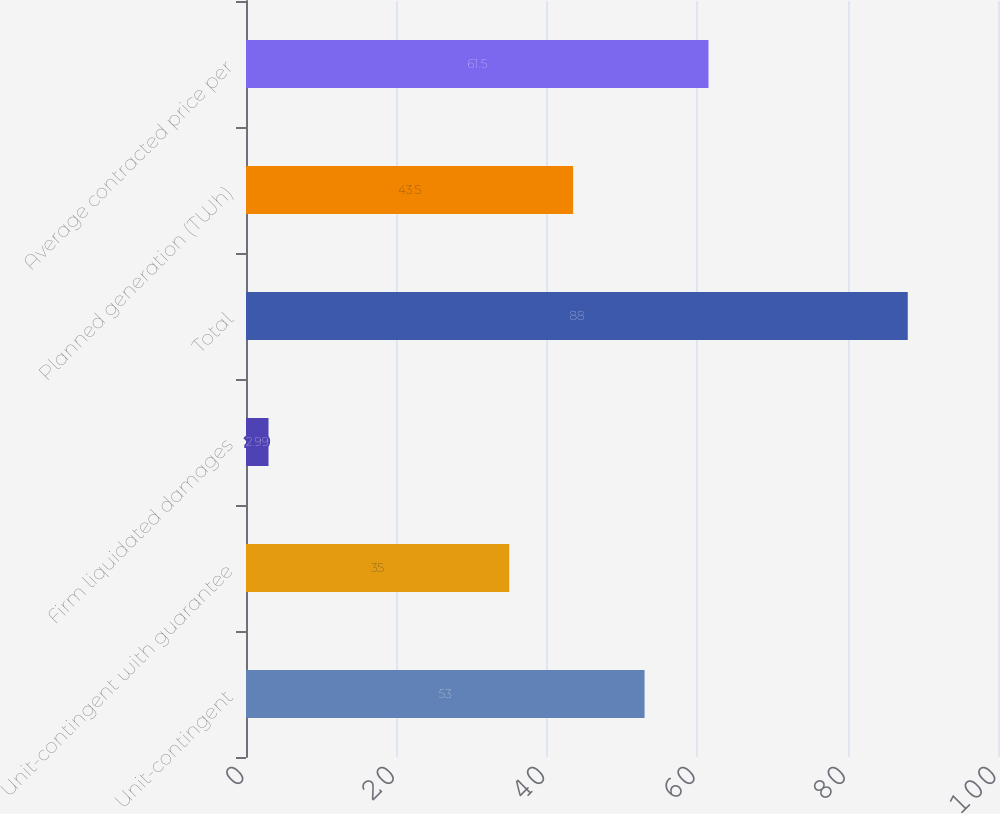Convert chart to OTSL. <chart><loc_0><loc_0><loc_500><loc_500><bar_chart><fcel>Unit-contingent<fcel>Unit-contingent with guarantee<fcel>Firm liquidated damages<fcel>Total<fcel>Planned generation (TWh)<fcel>Average contracted price per<nl><fcel>53<fcel>35<fcel>2.99<fcel>88<fcel>43.5<fcel>61.5<nl></chart> 